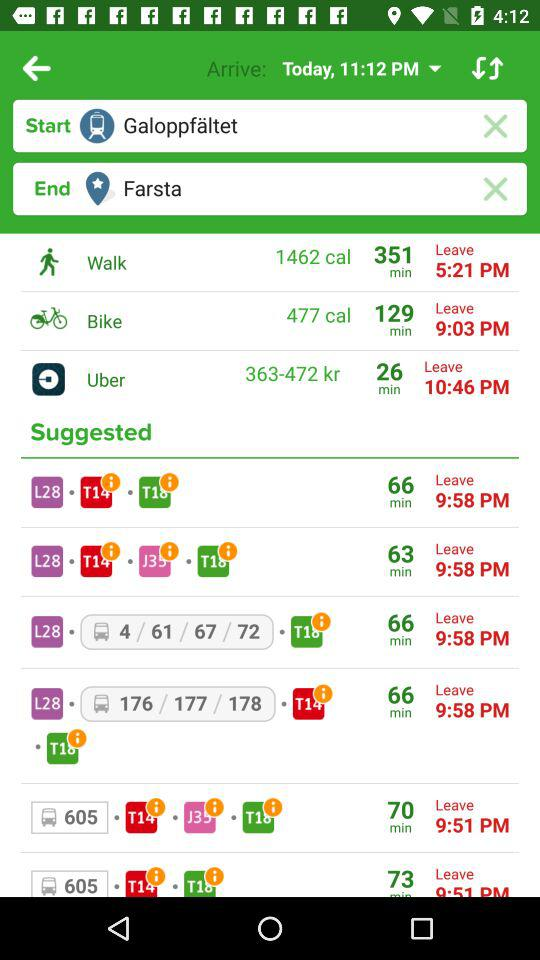How many calories does a "Walk" burn? A "Walk" burns 1462 calories. 